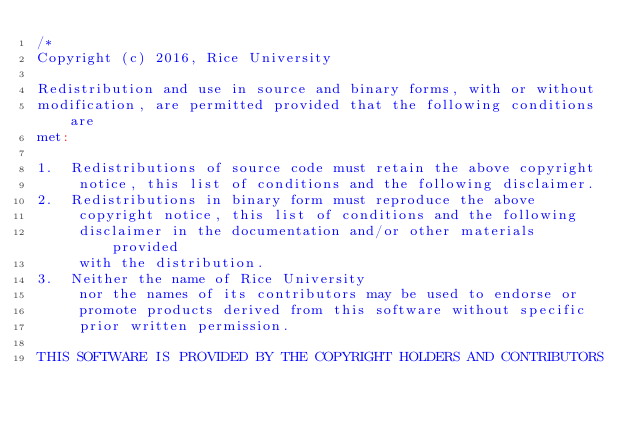Convert code to text. <code><loc_0><loc_0><loc_500><loc_500><_Scala_>/*
Copyright (c) 2016, Rice University

Redistribution and use in source and binary forms, with or without
modification, are permitted provided that the following conditions are
met:

1.  Redistributions of source code must retain the above copyright
     notice, this list of conditions and the following disclaimer.
2.  Redistributions in binary form must reproduce the above
     copyright notice, this list of conditions and the following
     disclaimer in the documentation and/or other materials provided
     with the distribution.
3.  Neither the name of Rice University
     nor the names of its contributors may be used to endorse or
     promote products derived from this software without specific
     prior written permission.

THIS SOFTWARE IS PROVIDED BY THE COPYRIGHT HOLDERS AND CONTRIBUTORS</code> 